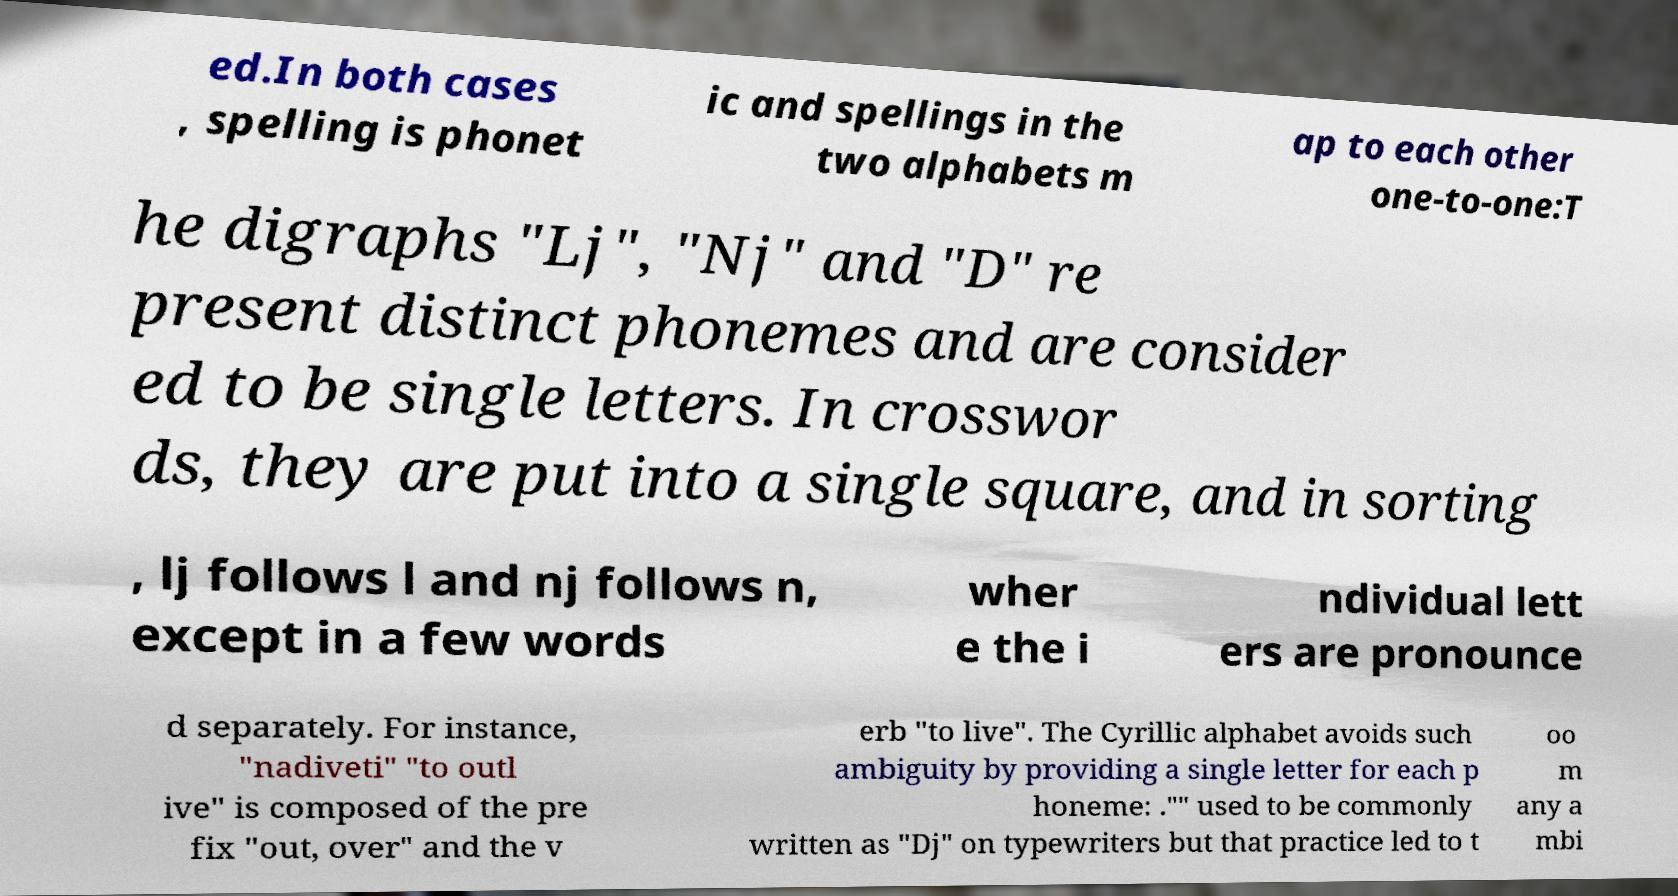There's text embedded in this image that I need extracted. Can you transcribe it verbatim? ed.In both cases , spelling is phonet ic and spellings in the two alphabets m ap to each other one-to-one:T he digraphs "Lj", "Nj" and "D" re present distinct phonemes and are consider ed to be single letters. In crosswor ds, they are put into a single square, and in sorting , lj follows l and nj follows n, except in a few words wher e the i ndividual lett ers are pronounce d separately. For instance, "nadiveti" "to outl ive" is composed of the pre fix "out, over" and the v erb "to live". The Cyrillic alphabet avoids such ambiguity by providing a single letter for each p honeme: ."" used to be commonly written as "Dj" on typewriters but that practice led to t oo m any a mbi 